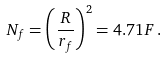<formula> <loc_0><loc_0><loc_500><loc_500>N _ { f } = \left ( \frac { R } { r _ { f } } \right ) ^ { 2 } = 4 . 7 1 F \, .</formula> 